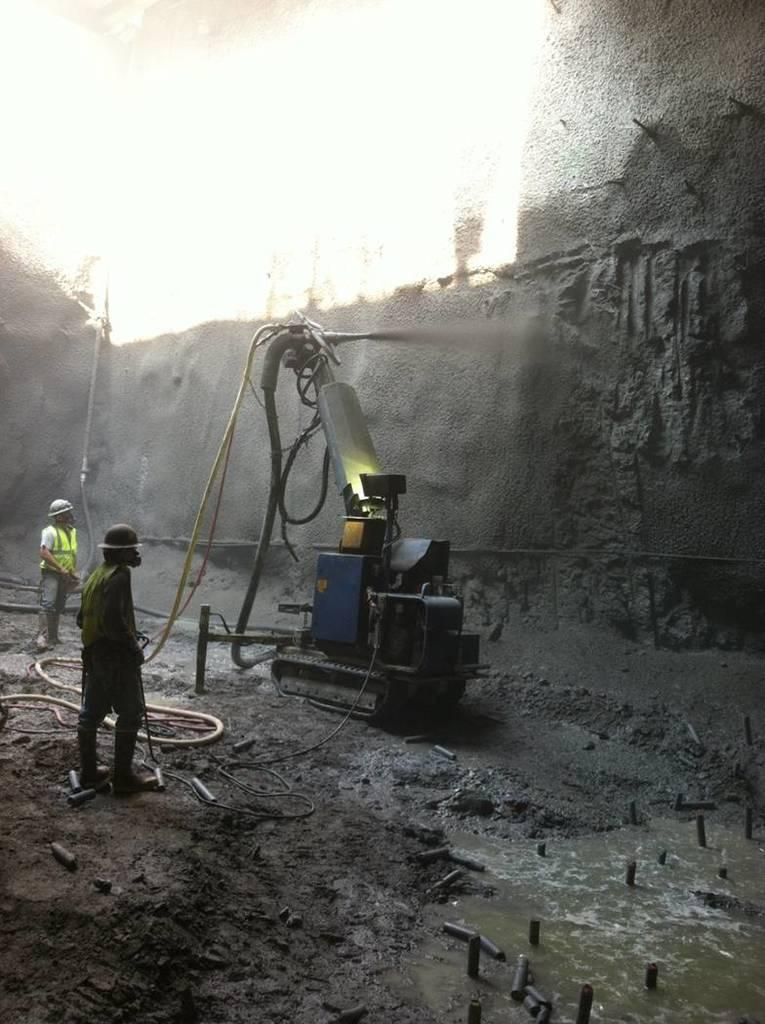What is located at the front of the image? There is water in the front of the image. What can be seen in the center of the image? There is a machine in the center of the image. Are there any people present in the image? Yes, there are persons standing in the image. What is visible in the background of the image? There is a wall in the background of the image. Can you tell me how many tents are set up near the machine in the image? There are no tents present in the image; it features water, a machine, and persons standing near a wall. What type of unit is being used to process the water in the image? There is no specific unit mentioned in the image, only a machine is visible. 